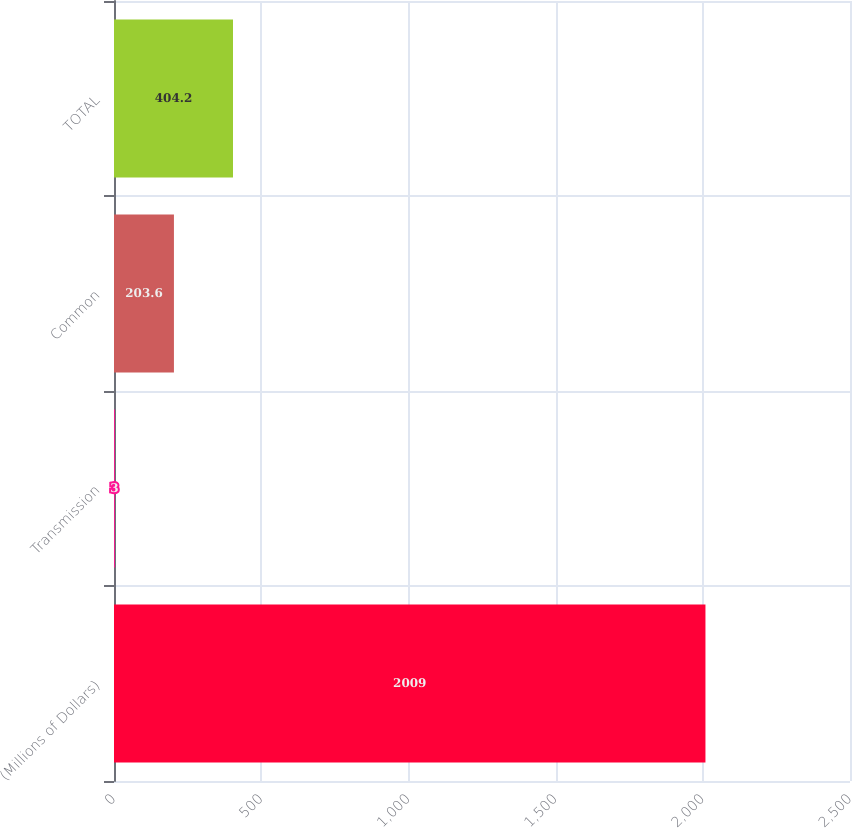<chart> <loc_0><loc_0><loc_500><loc_500><bar_chart><fcel>(Millions of Dollars)<fcel>Transmission<fcel>Common<fcel>TOTAL<nl><fcel>2009<fcel>3<fcel>203.6<fcel>404.2<nl></chart> 